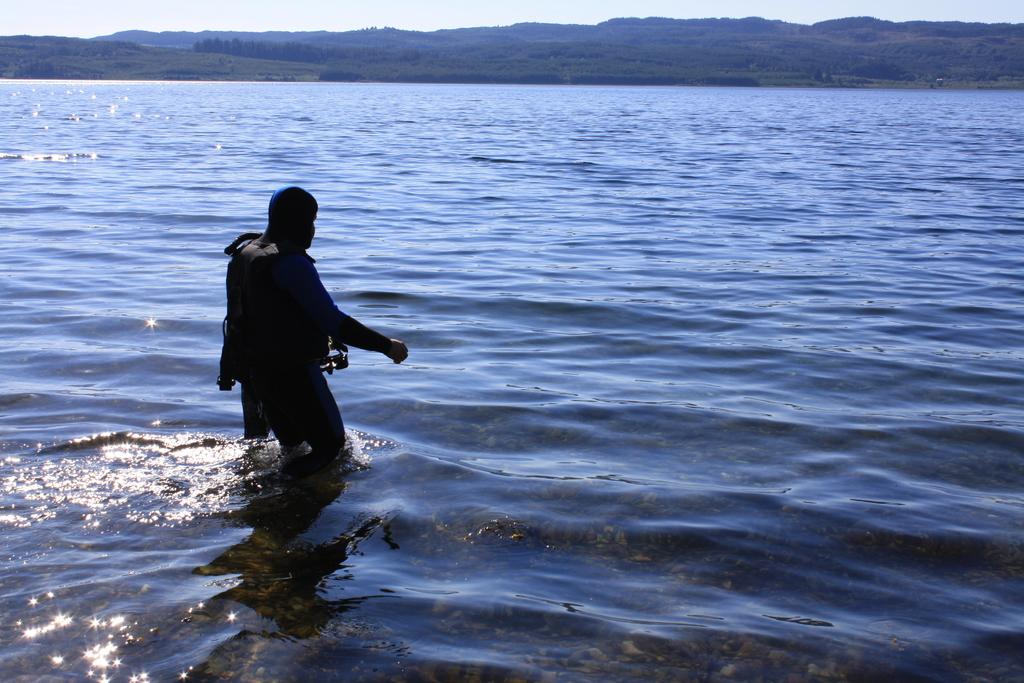Where was the picture taken? The picture was clicked outside the city. What is the person in the image doing? The person is in a water body on the left side of the image. What can be seen in the background of the image? The sky, trees, hills, and other unspecified objects are visible in the background of the image. Where is the baseball game being played in the image? There is no baseball game or any reference to a baseball game in the image. 